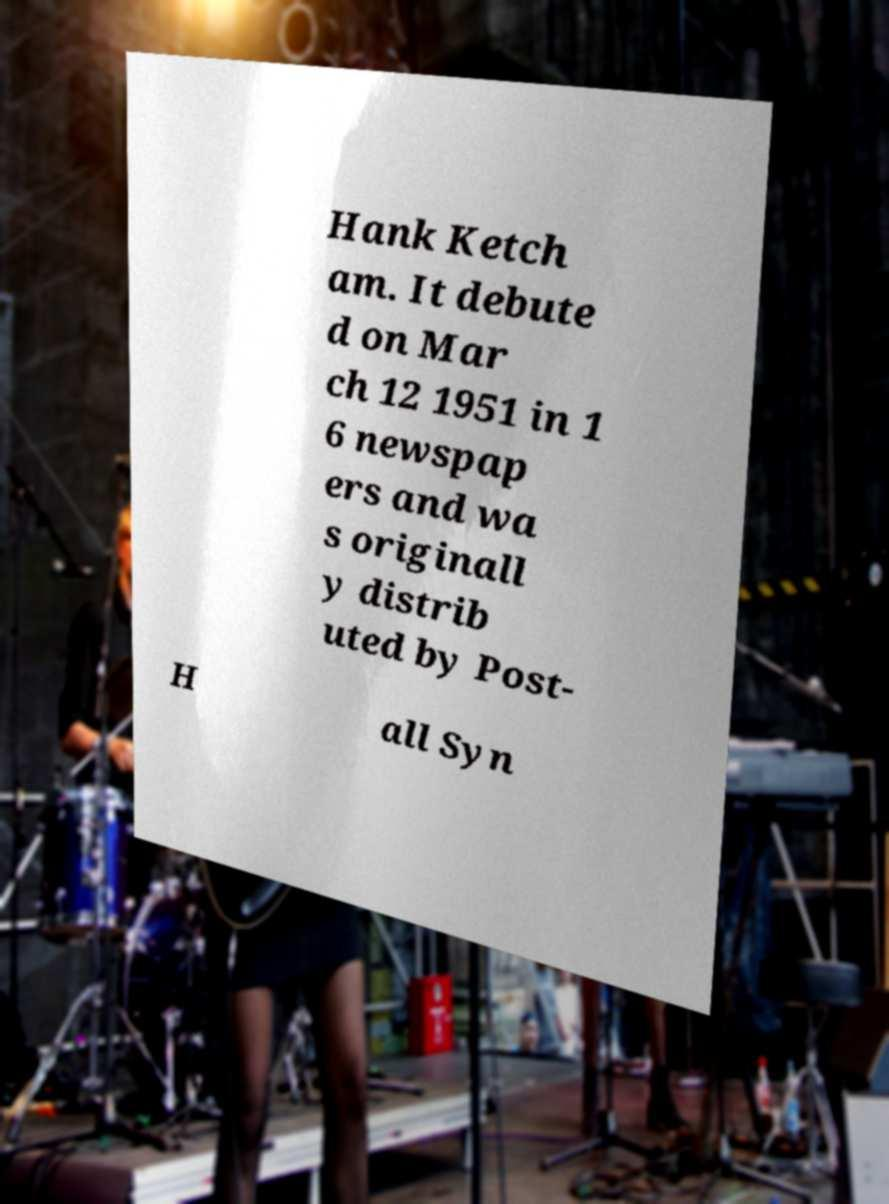Please read and relay the text visible in this image. What does it say? Hank Ketch am. It debute d on Mar ch 12 1951 in 1 6 newspap ers and wa s originall y distrib uted by Post- H all Syn 